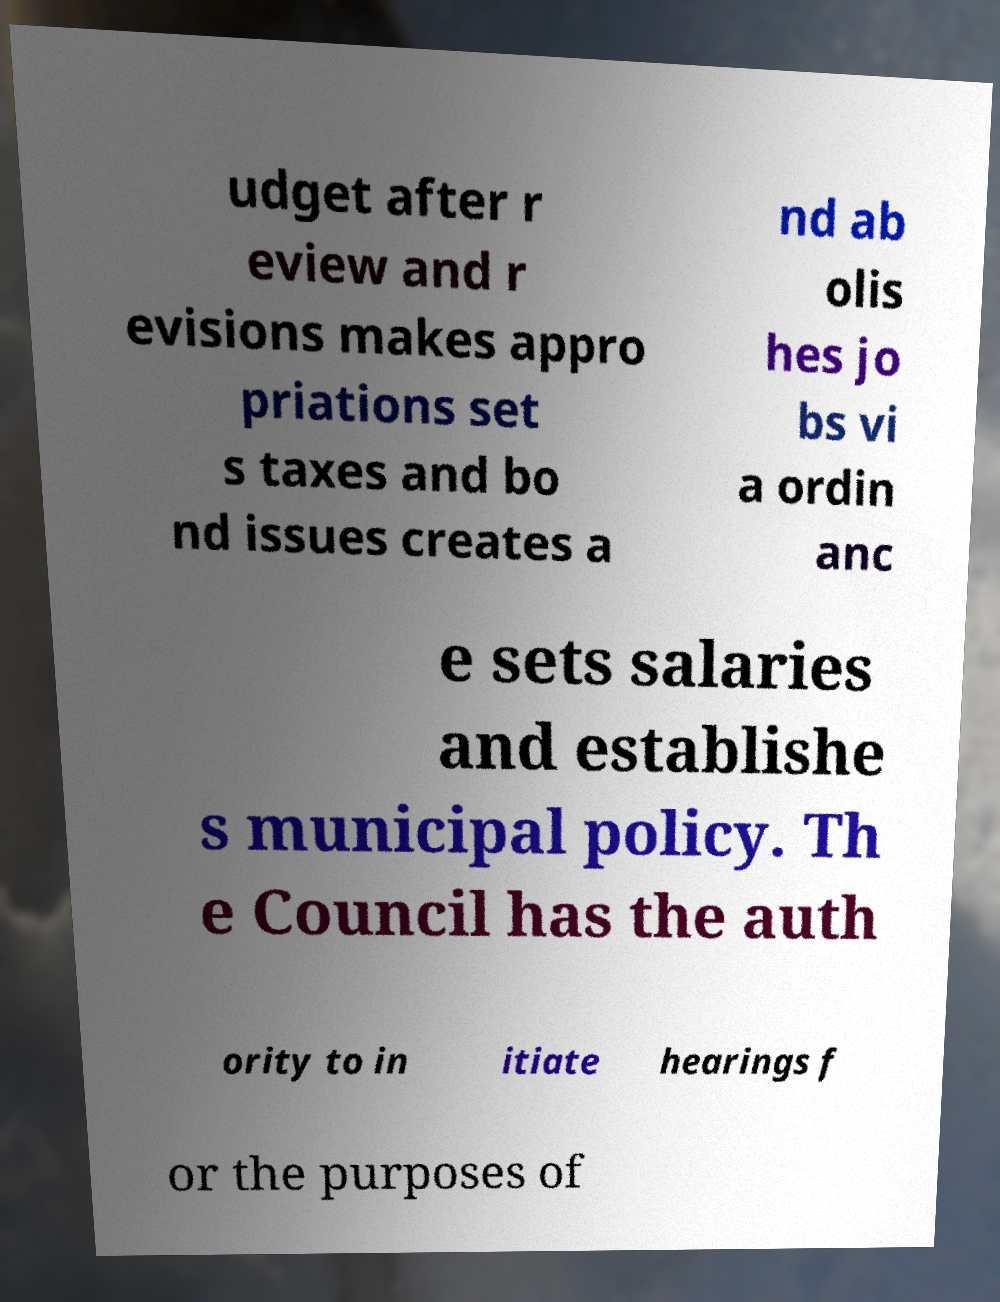What messages or text are displayed in this image? I need them in a readable, typed format. udget after r eview and r evisions makes appro priations set s taxes and bo nd issues creates a nd ab olis hes jo bs vi a ordin anc e sets salaries and establishe s municipal policy. Th e Council has the auth ority to in itiate hearings f or the purposes of 